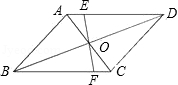Explain the details depicted in the figure. In the diagram, there is a parallelogram labeled ABCD. The diagonals of this parallelogram intersect at a point labeled O. There is also a line labeled EF that intersects point O and extends to intersect side AD at a point labeled E and side BC at a point labeled F. 